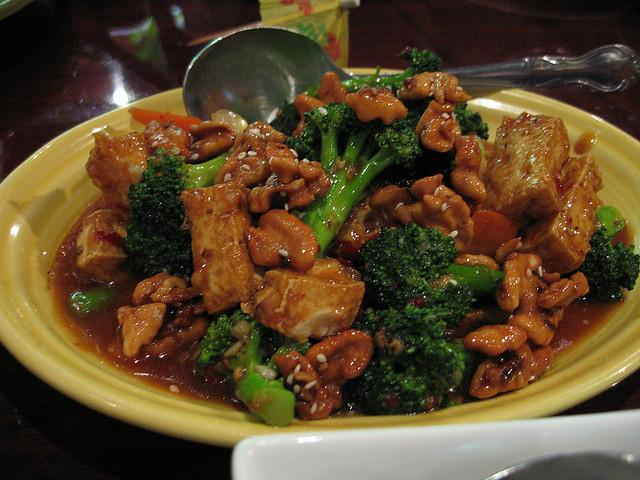What is the food covered in to make it orange? sauce 